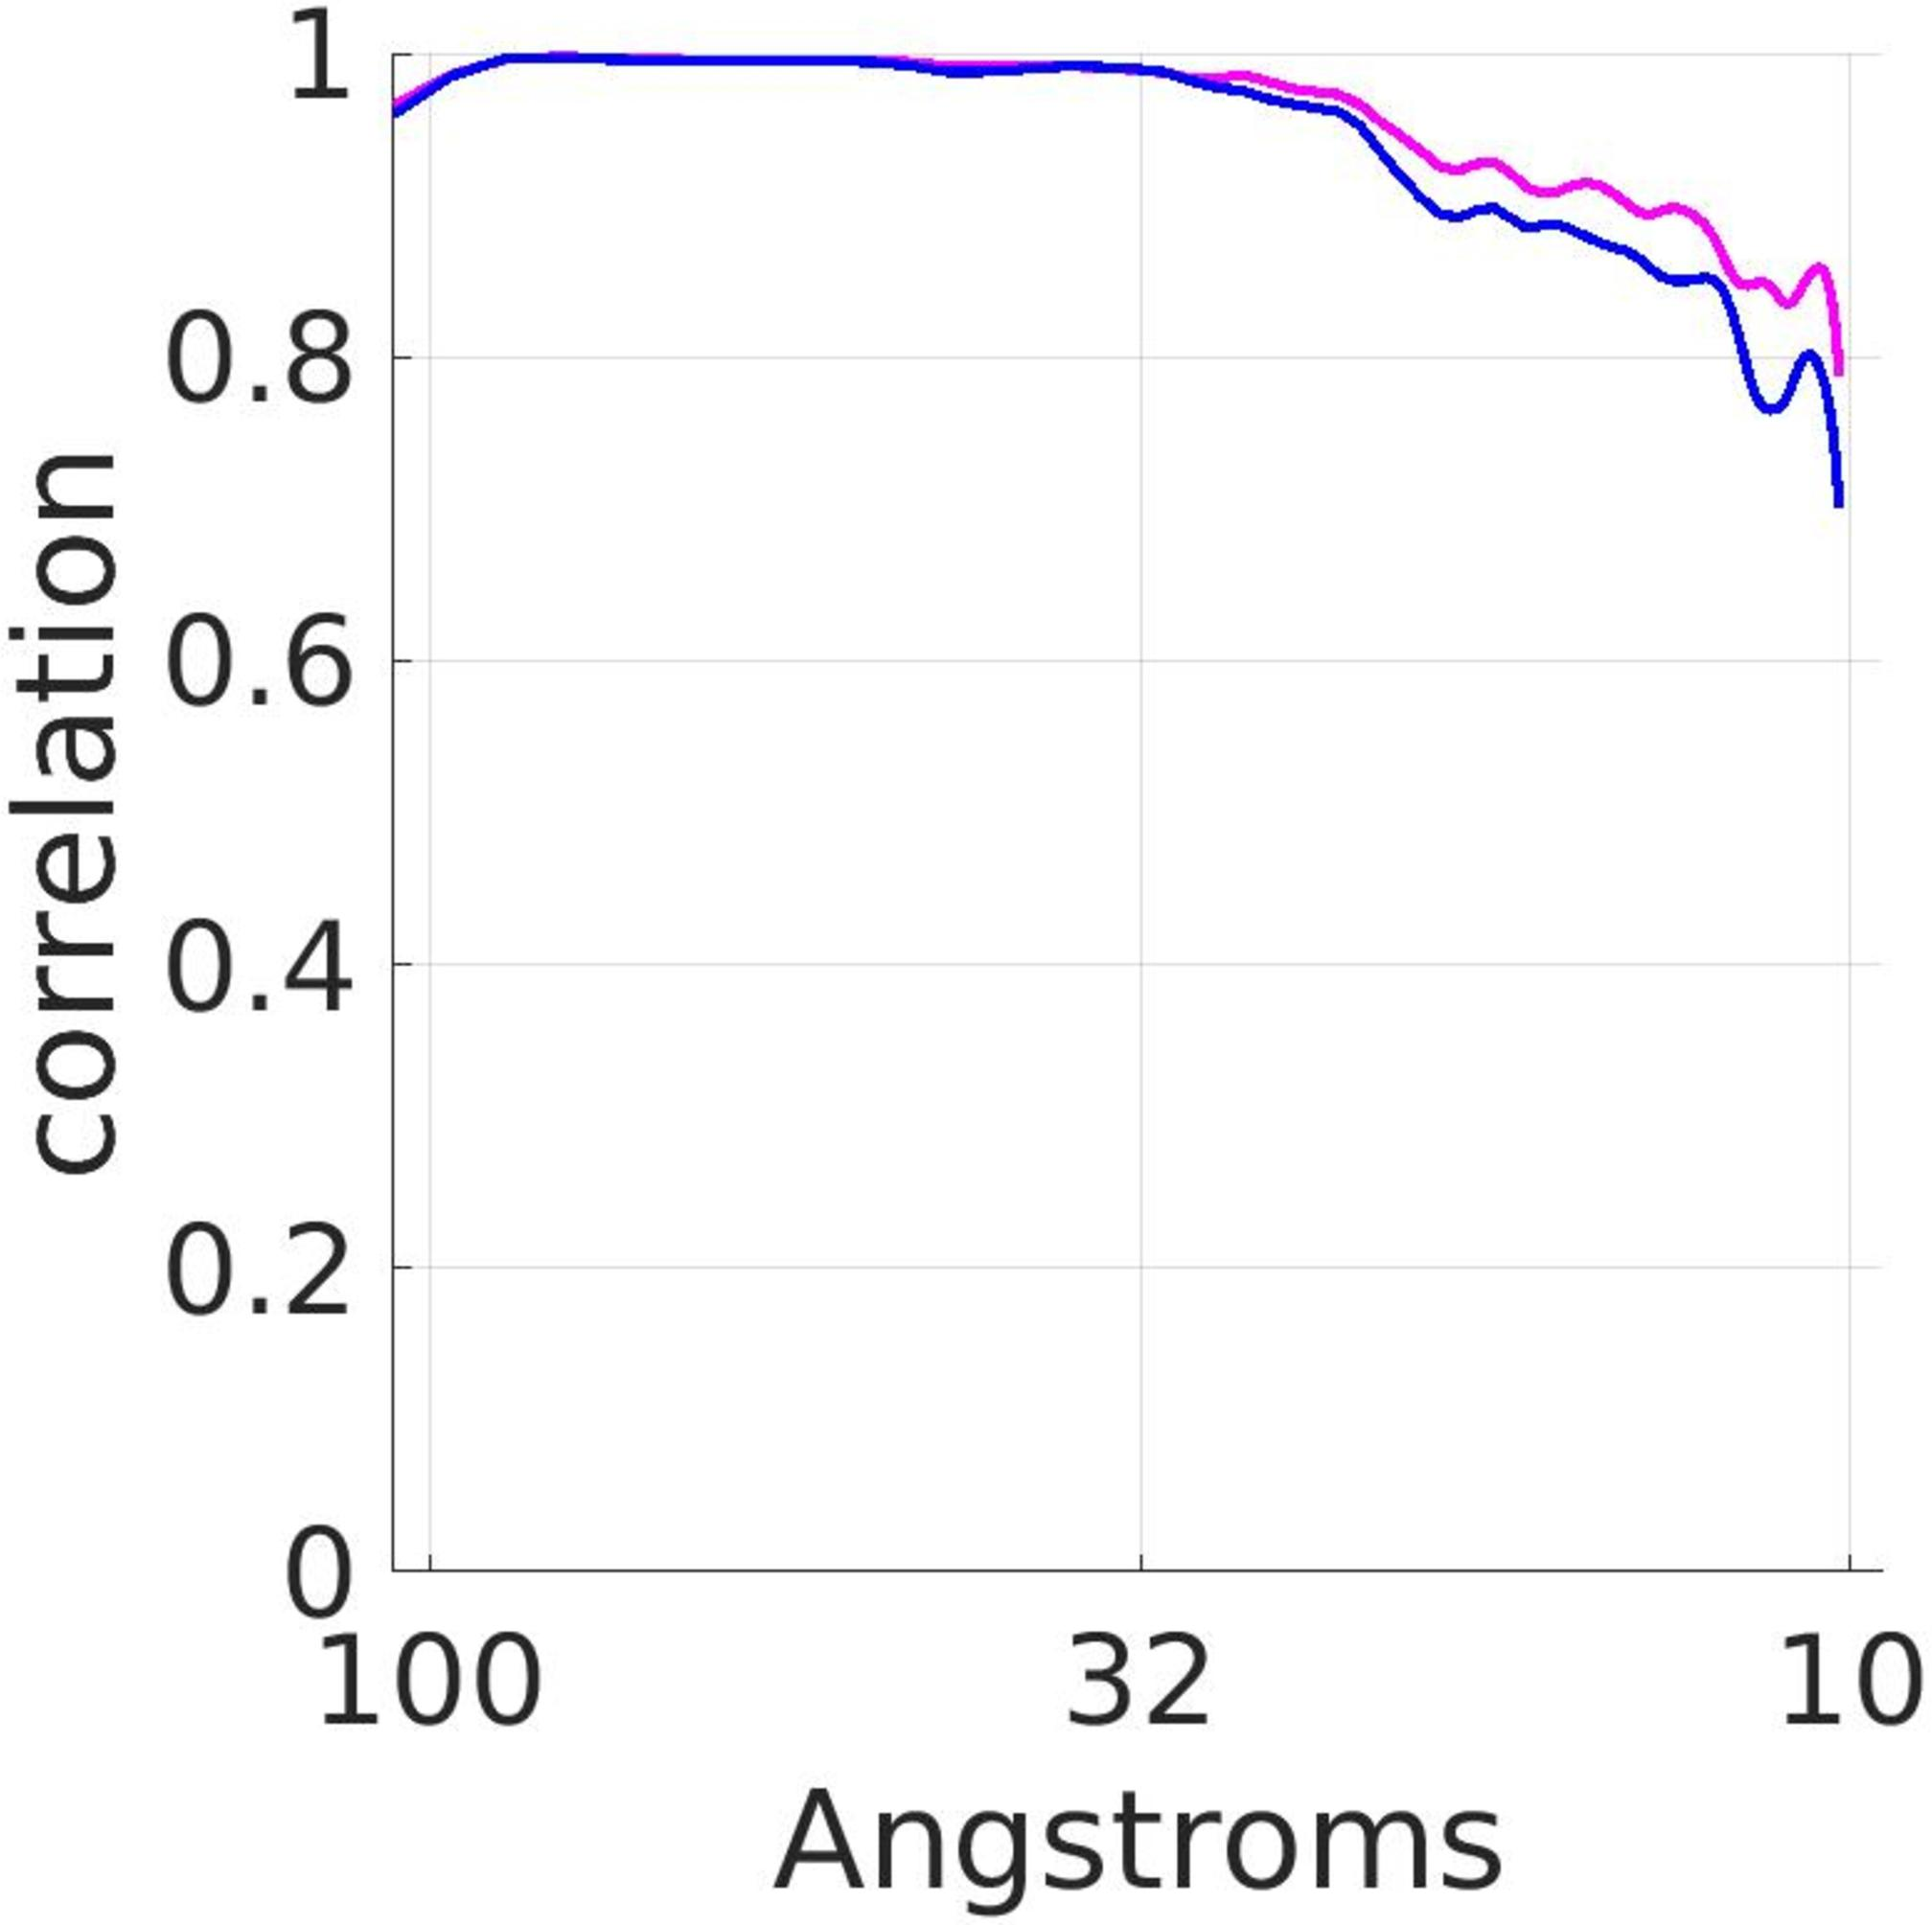Can you explain why the correlation tends to decrease as the distance increases according to the graph? The correlation decrease with increasing distance is often a typical phenomenon in spatially dependent measurements, which can be explained by the influence of spatial separation diminishing the similarity or interaction strength between measurements. As distance increases, factors such as signal attenuation, diffusion effects, or simply increasing spatial independence might play roles, causing overall lower correlation values. 